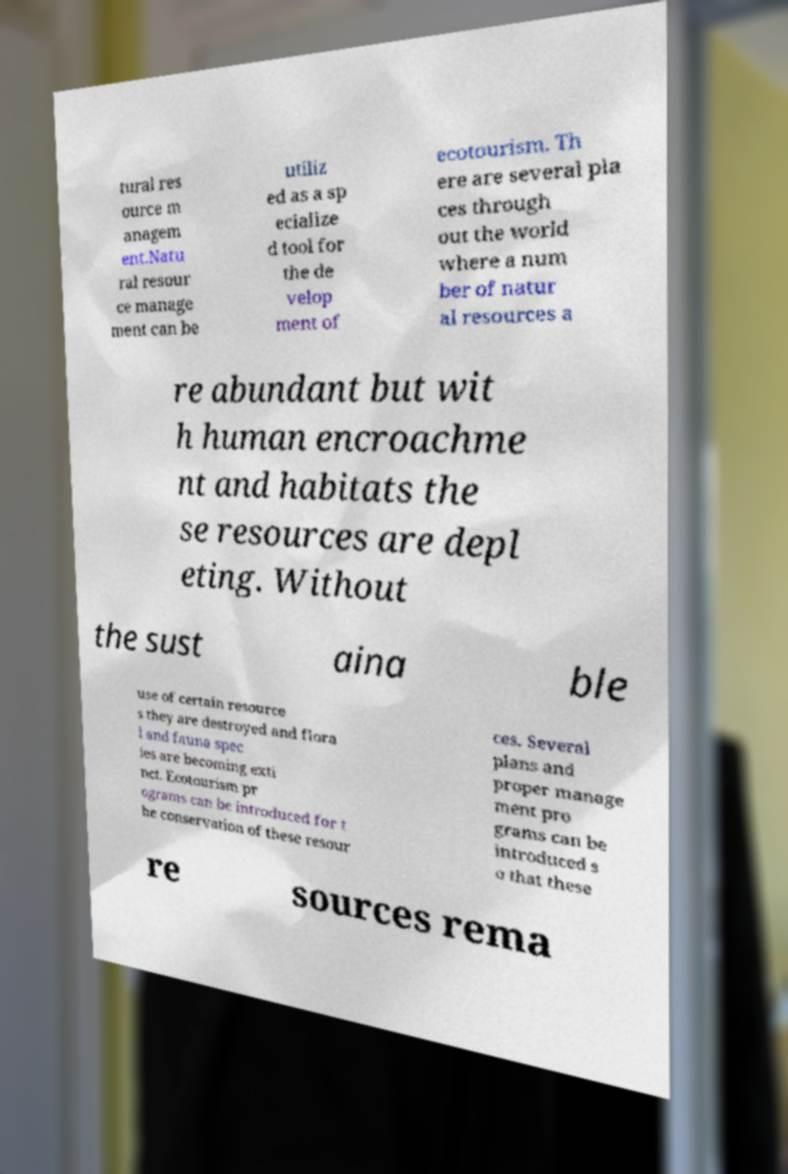For documentation purposes, I need the text within this image transcribed. Could you provide that? tural res ource m anagem ent.Natu ral resour ce manage ment can be utiliz ed as a sp ecialize d tool for the de velop ment of ecotourism. Th ere are several pla ces through out the world where a num ber of natur al resources a re abundant but wit h human encroachme nt and habitats the se resources are depl eting. Without the sust aina ble use of certain resource s they are destroyed and flora l and fauna spec ies are becoming exti nct. Ecotourism pr ograms can be introduced for t he conservation of these resour ces. Several plans and proper manage ment pro grams can be introduced s o that these re sources rema 